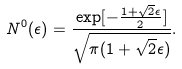Convert formula to latex. <formula><loc_0><loc_0><loc_500><loc_500>N ^ { 0 } ( \epsilon ) = \frac { \exp [ - \frac { 1 + \sqrt { 2 } \epsilon } { 2 } ] } { \sqrt { \pi ( 1 + \sqrt { 2 } \epsilon ) } } .</formula> 